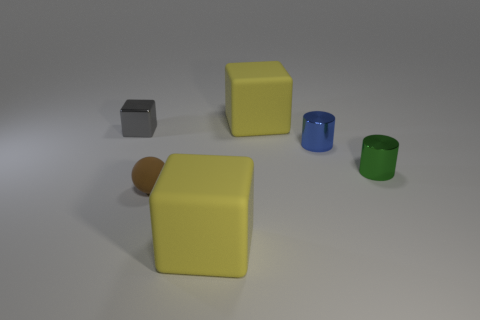Add 4 yellow cubes. How many objects exist? 10 Subtract all spheres. How many objects are left? 5 Subtract 0 red blocks. How many objects are left? 6 Subtract all tiny cylinders. Subtract all large green matte cylinders. How many objects are left? 4 Add 1 tiny metallic things. How many tiny metallic things are left? 4 Add 6 big yellow cubes. How many big yellow cubes exist? 8 